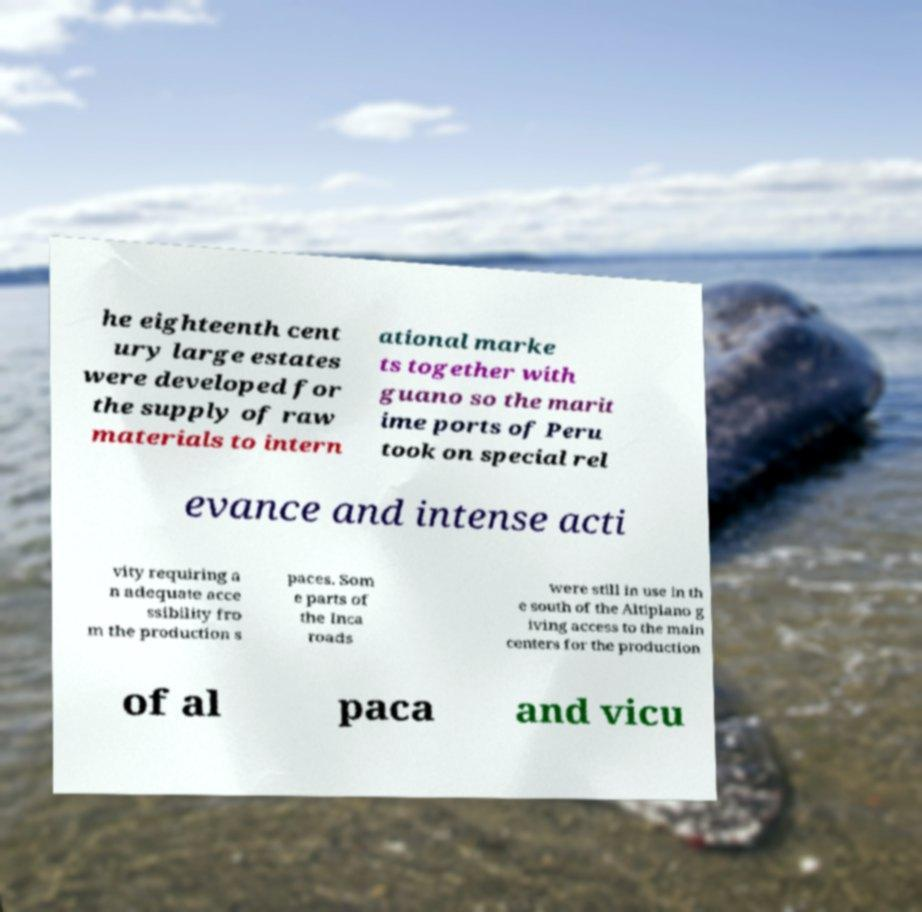Could you extract and type out the text from this image? he eighteenth cent ury large estates were developed for the supply of raw materials to intern ational marke ts together with guano so the marit ime ports of Peru took on special rel evance and intense acti vity requiring a n adequate acce ssibility fro m the production s paces. Som e parts of the Inca roads were still in use in th e south of the Altiplano g iving access to the main centers for the production of al paca and vicu 